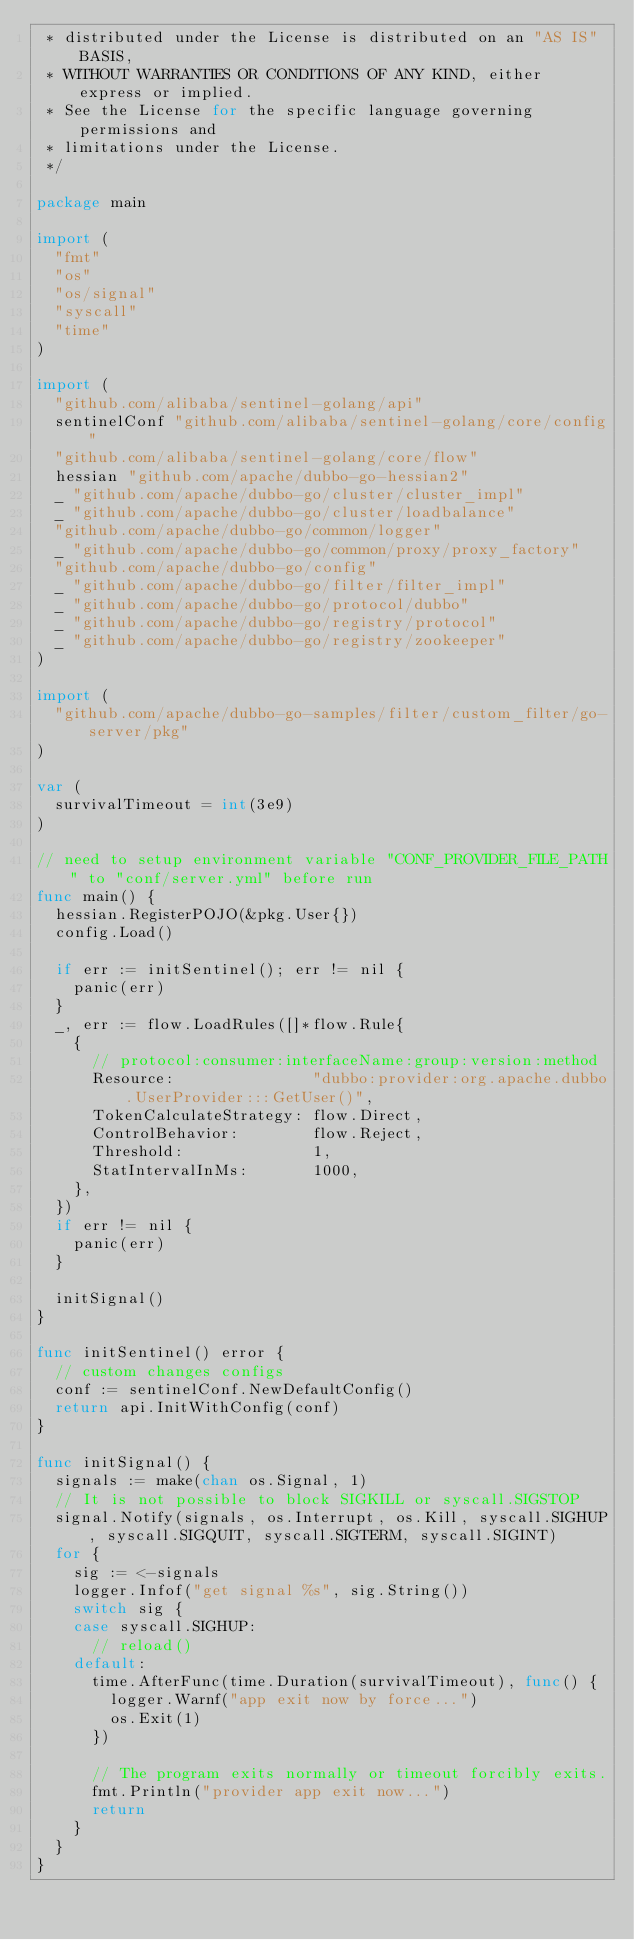<code> <loc_0><loc_0><loc_500><loc_500><_Go_> * distributed under the License is distributed on an "AS IS" BASIS,
 * WITHOUT WARRANTIES OR CONDITIONS OF ANY KIND, either express or implied.
 * See the License for the specific language governing permissions and
 * limitations under the License.
 */

package main

import (
	"fmt"
	"os"
	"os/signal"
	"syscall"
	"time"
)

import (
	"github.com/alibaba/sentinel-golang/api"
	sentinelConf "github.com/alibaba/sentinel-golang/core/config"
	"github.com/alibaba/sentinel-golang/core/flow"
	hessian "github.com/apache/dubbo-go-hessian2"
	_ "github.com/apache/dubbo-go/cluster/cluster_impl"
	_ "github.com/apache/dubbo-go/cluster/loadbalance"
	"github.com/apache/dubbo-go/common/logger"
	_ "github.com/apache/dubbo-go/common/proxy/proxy_factory"
	"github.com/apache/dubbo-go/config"
	_ "github.com/apache/dubbo-go/filter/filter_impl"
	_ "github.com/apache/dubbo-go/protocol/dubbo"
	_ "github.com/apache/dubbo-go/registry/protocol"
	_ "github.com/apache/dubbo-go/registry/zookeeper"
)

import (
	"github.com/apache/dubbo-go-samples/filter/custom_filter/go-server/pkg"
)

var (
	survivalTimeout = int(3e9)
)

// need to setup environment variable "CONF_PROVIDER_FILE_PATH" to "conf/server.yml" before run
func main() {
	hessian.RegisterPOJO(&pkg.User{})
	config.Load()

	if err := initSentinel(); err != nil {
		panic(err)
	}
	_, err := flow.LoadRules([]*flow.Rule{
		{
			// protocol:consumer:interfaceName:group:version:method
			Resource:               "dubbo:provider:org.apache.dubbo.UserProvider:::GetUser()",
			TokenCalculateStrategy: flow.Direct,
			ControlBehavior:        flow.Reject,
			Threshold:              1,
			StatIntervalInMs:       1000,
		},
	})
	if err != nil {
		panic(err)
	}

	initSignal()
}

func initSentinel() error {
	// custom changes configs
	conf := sentinelConf.NewDefaultConfig()
	return api.InitWithConfig(conf)
}

func initSignal() {
	signals := make(chan os.Signal, 1)
	// It is not possible to block SIGKILL or syscall.SIGSTOP
	signal.Notify(signals, os.Interrupt, os.Kill, syscall.SIGHUP, syscall.SIGQUIT, syscall.SIGTERM, syscall.SIGINT)
	for {
		sig := <-signals
		logger.Infof("get signal %s", sig.String())
		switch sig {
		case syscall.SIGHUP:
			// reload()
		default:
			time.AfterFunc(time.Duration(survivalTimeout), func() {
				logger.Warnf("app exit now by force...")
				os.Exit(1)
			})

			// The program exits normally or timeout forcibly exits.
			fmt.Println("provider app exit now...")
			return
		}
	}
}
</code> 